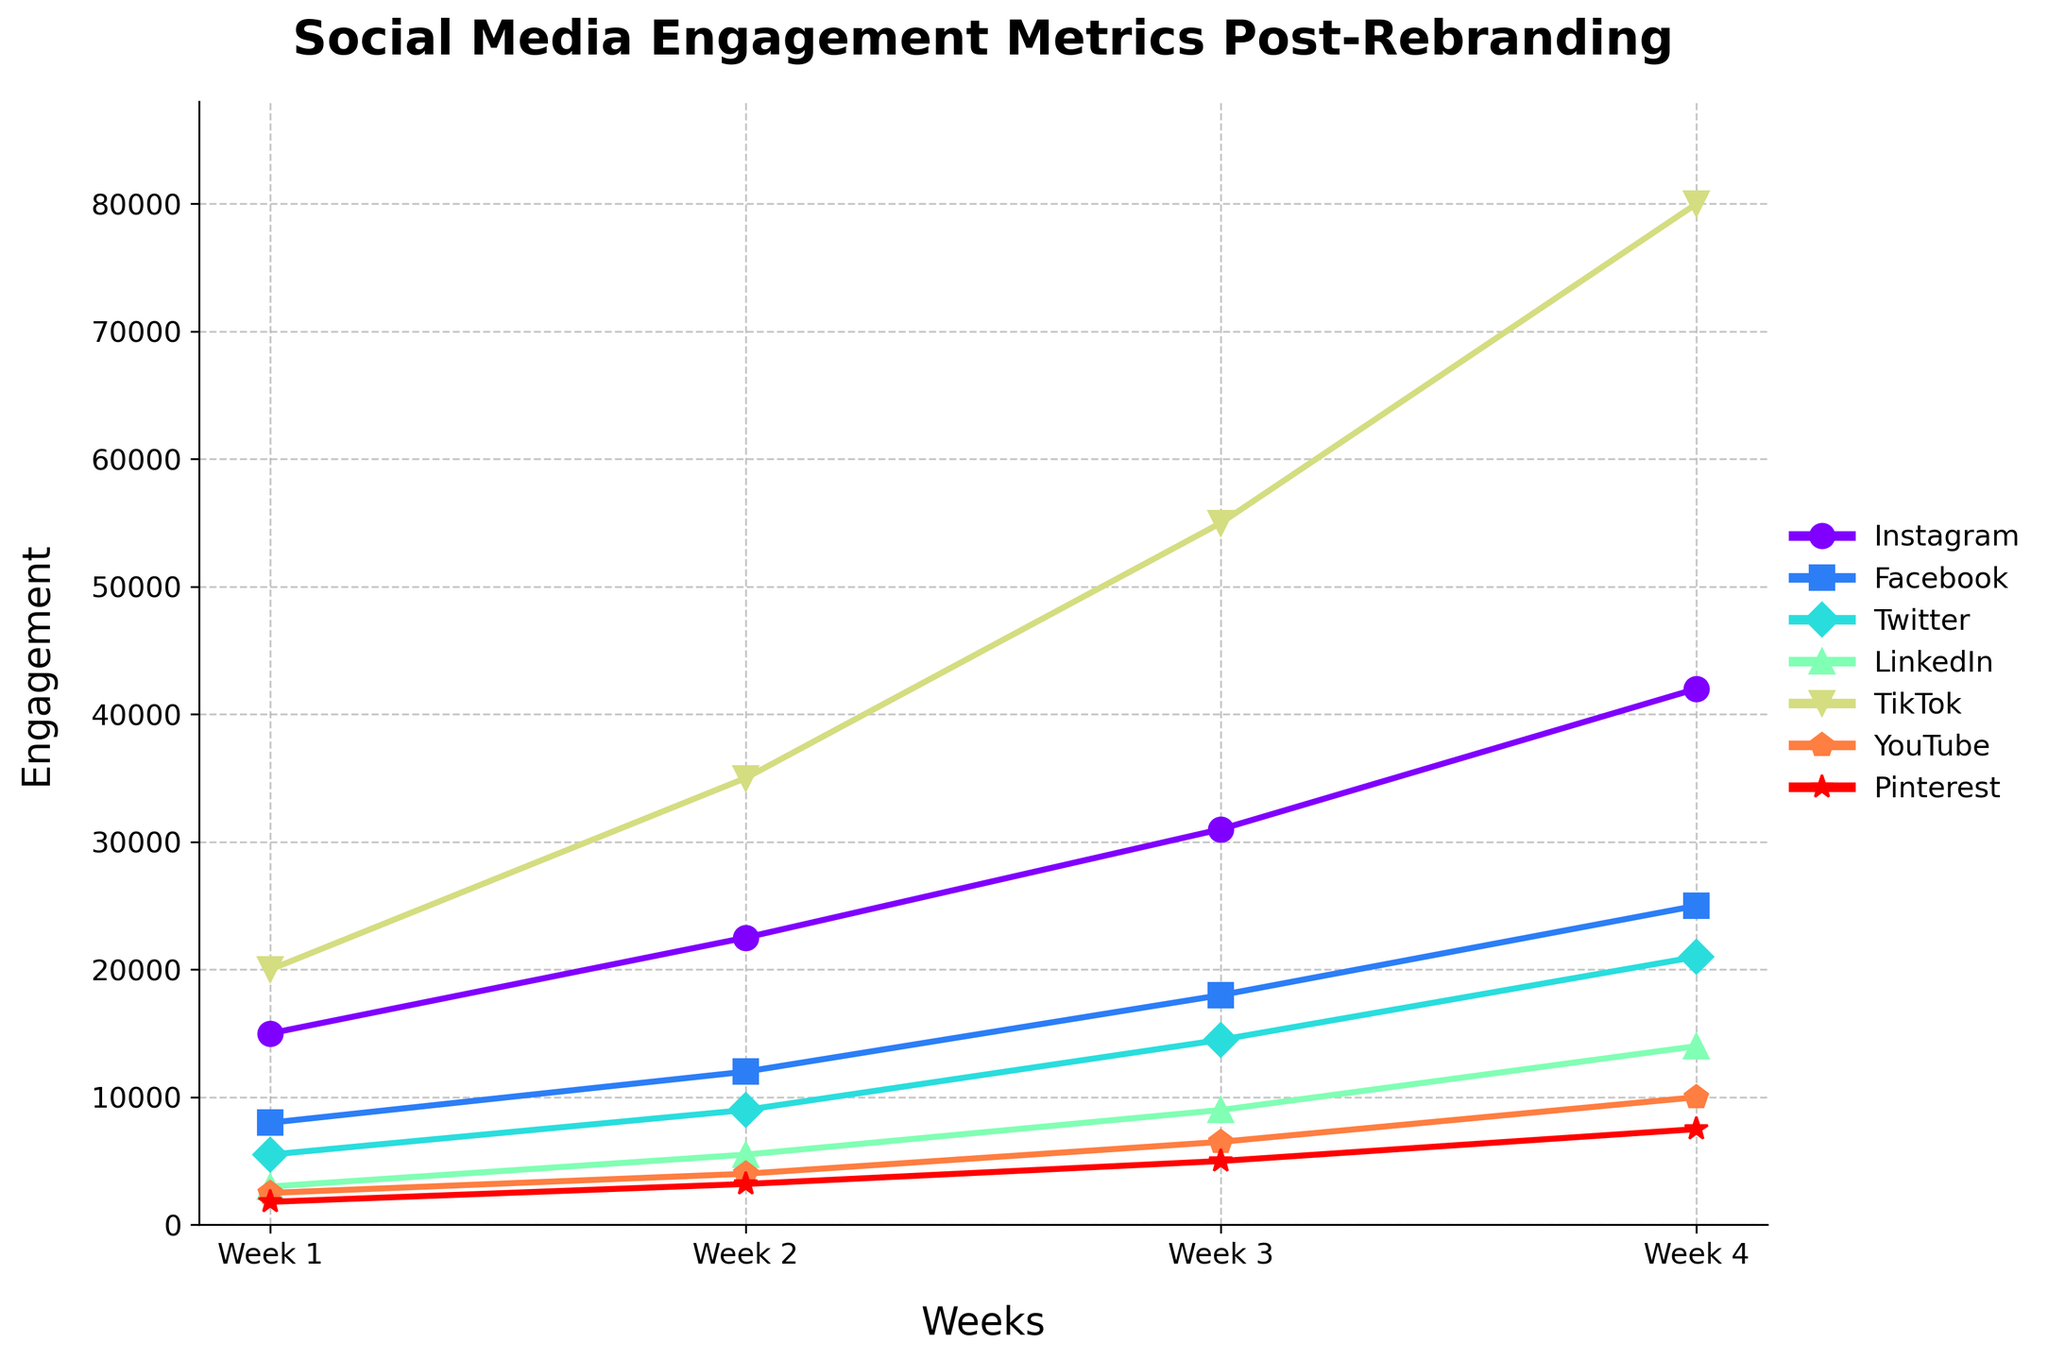What platform had the highest engagement in Week 4? Look at the engagement values in Week 4 for all platforms. TikTok had the highest value at 80,000.
Answer: TikTok What is the total engagement across all platforms in Week 3? Add the engagement values for all platforms in Week 3: 31,000 (Instagram) + 18,000 (Facebook) + 14,500 (Twitter) + 9,000 (LinkedIn) + 55,000 (TikTok) + 6,500 (YouTube) + 5,000 (Pinterest). The total is 139,000.
Answer: 139,000 How does Instagram's engagement growth compare to Facebook's from Week 1 to Week 4? Calculate the increase for both platforms. Instagram's growth: 42,000 - 15,000 = 27,000. Facebook's growth: 25,000 - 8,000 = 17,000. Instagram's engagement growth is larger by 10,000.
Answer: Instagram’s growth is larger by 10,000 Which platform showed the most significant increase in engagement from Week 2 to Week 3? Look at the changes from Week 2 to Week 3: Instagram (31,000 - 22,500 = 8,500), Facebook (18,000 - 12,000 = 6,000), Twitter (14,500 - 9,000 = 5,500), LinkedIn (9,000 - 5,500 = 3,500), TikTok (55,000 - 35,000 = 20,000), YouTube (6,500 - 4,000 = 2,500), Pinterest (5,000 - 3,200 = 1,800). TikTok has the largest increase at 20,000.
Answer: TikTok Rank the platforms based on their engagement in Week 1. List the platforms in descending order of their Week 1 engagement values: TikTok (20,000), Instagram (15,000), Facebook (8,000), Twitter (5,500), LinkedIn (3,000), YouTube (2,500), Pinterest (1,800).
Answer: TikTok, Instagram, Facebook, Twitter, LinkedIn, YouTube, Pinterest Which platform had the smallest difference between the Week 2 and Week 4 engagement metrics? Calculate differences: Instagram (42,000 - 22,500 = 19,500), Facebook (25,000 - 12,000 = 13,000), Twitter (21,000 - 9,000 = 12,000), LinkedIn (14,000 - 5,500 = 8,500), TikTok (80,000 - 35,000 = 45,000), YouTube (10,000 - 4,000 = 6,000), Pinterest (7,500 - 3,200 = 4,300). Pinterest has the smallest difference at 4,300.
Answer: Pinterest By how much did YouTube's engagement grow from Week 1 to Week 4? Calculate the difference: 10,000 (Week 4) - 2,500 (Week 1) = 7,500.
Answer: 7,500 Which week showed the highest average engagement across all platforms? Calculate the average engagement for each week. Week 1: (15,000 + 8,000 + 5,500 + 3,000 + 20,000 + 2,500 + 1,800) / 7 = 7,971. Week 2: (22,500 + 12,000 + 9,000 + 5,500 + 35,000 + 4,000 + 3,200) / 7 = 13,457. Week 3: (31,000 + 18,000 + 14,500 + 9,000 + 55,000 + 6,500 + 5,000) / 7 = 19,428. Week 4: (42,000 + 25,000 + 21,000 + 14,000 + 80,000 + 10,000 + 7,500) / 7 = 28,071. Week 4 has the highest average engagement.
Answer: Week 4 